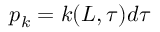Convert formula to latex. <formula><loc_0><loc_0><loc_500><loc_500>p _ { k } = k ( L , \tau ) d \tau</formula> 